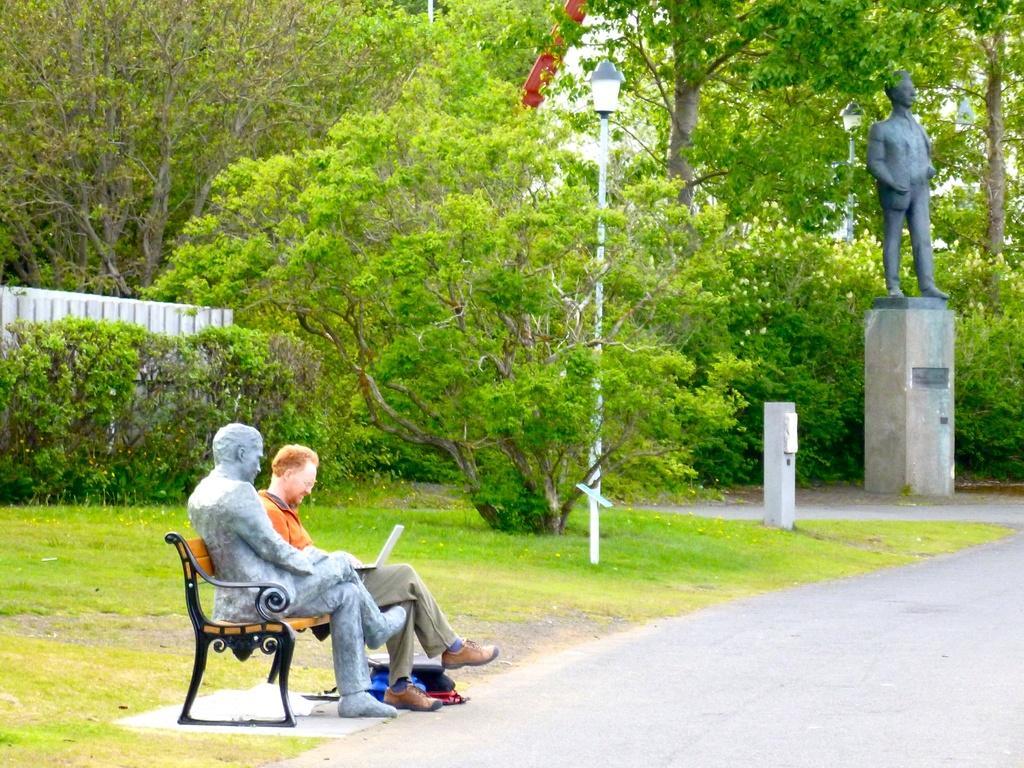Can you describe this image briefly? In this image, we can see some trees and street poles. There is a person and statue on bench which is in the bottom left of the image. There is an another statue on the right side of the image. 